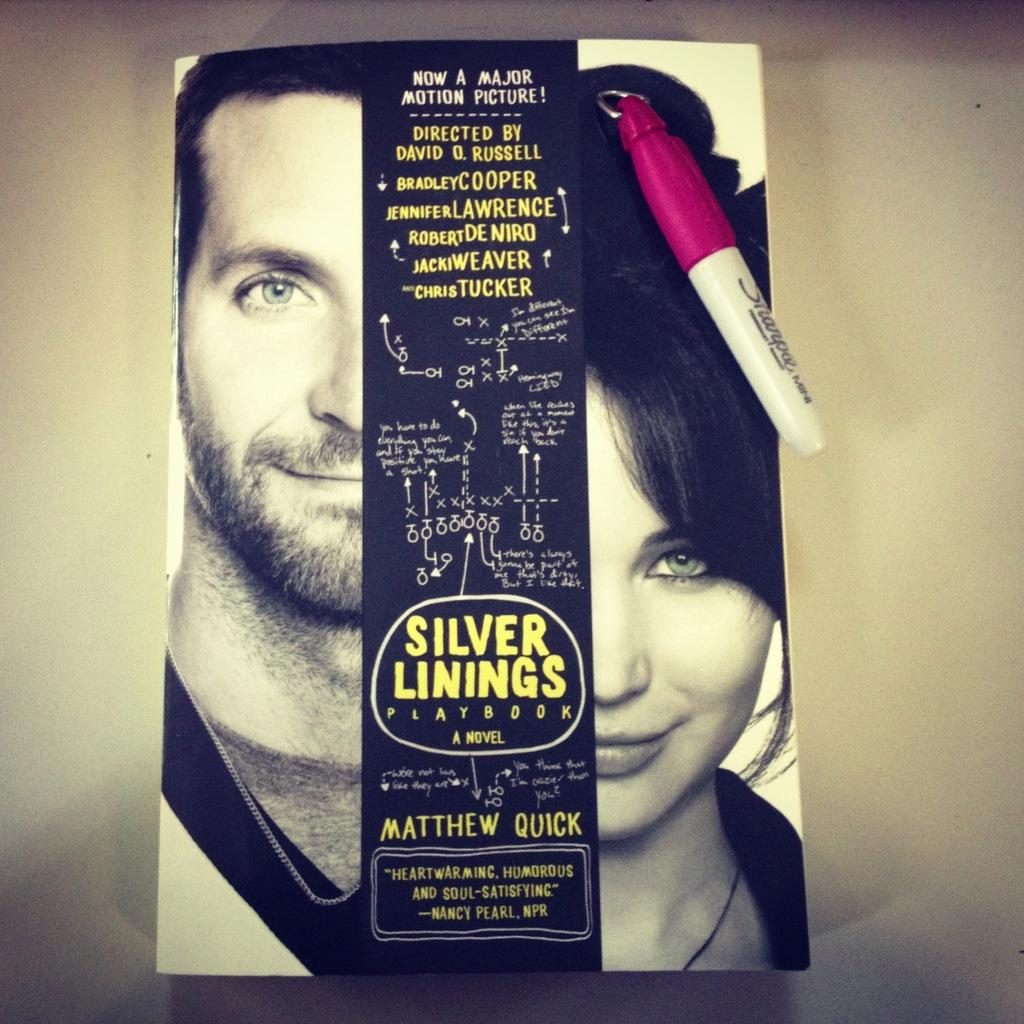What is depicted on the cover page of the book in the image? The cover page of the book contains a man and a woman. What is the color of the background on the cover page? The background of the cover page is a white color surface. Can you hear the man coughing on the cover page of the book in the image? There is no sound or indication of a cough on the cover page of the book in the image. What type of powder is being used by the woman on the cover page of the book in the image? There is no powder or any indication of its use on the cover page of the book in the image. 